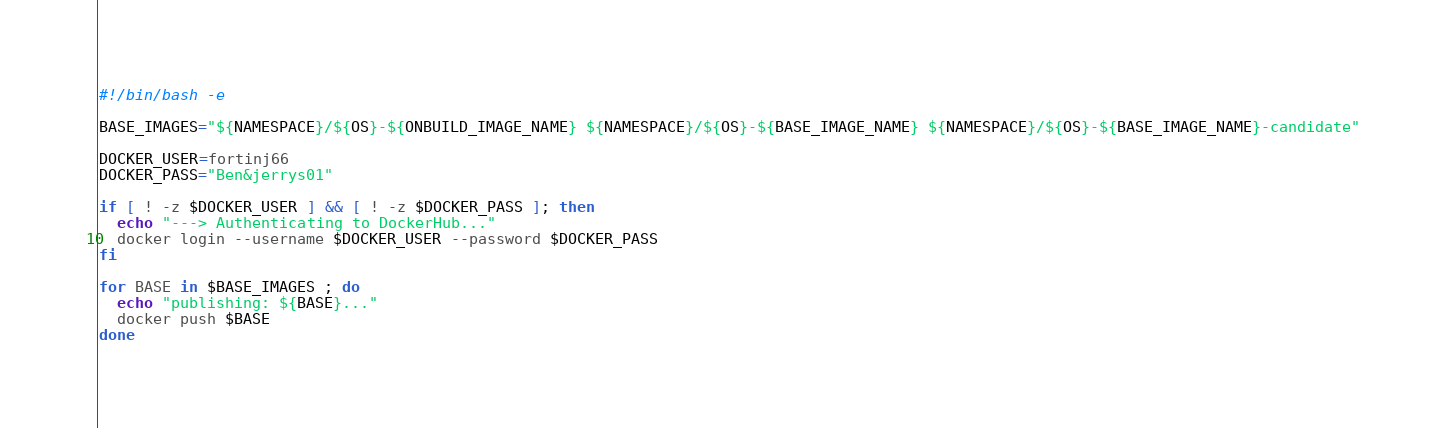<code> <loc_0><loc_0><loc_500><loc_500><_Bash_>#!/bin/bash -e

BASE_IMAGES="${NAMESPACE}/${OS}-${ONBUILD_IMAGE_NAME} ${NAMESPACE}/${OS}-${BASE_IMAGE_NAME} ${NAMESPACE}/${OS}-${BASE_IMAGE_NAME}-candidate"

DOCKER_USER=fortinj66
DOCKER_PASS="Ben&jerrys01"

if [ ! -z $DOCKER_USER ] && [ ! -z $DOCKER_PASS ]; then
  echo "---> Authenticating to DockerHub..."
  docker login --username $DOCKER_USER --password $DOCKER_PASS
fi

for BASE in $BASE_IMAGES ; do
  echo "publishing: ${BASE}..."
  docker push $BASE
done
</code> 